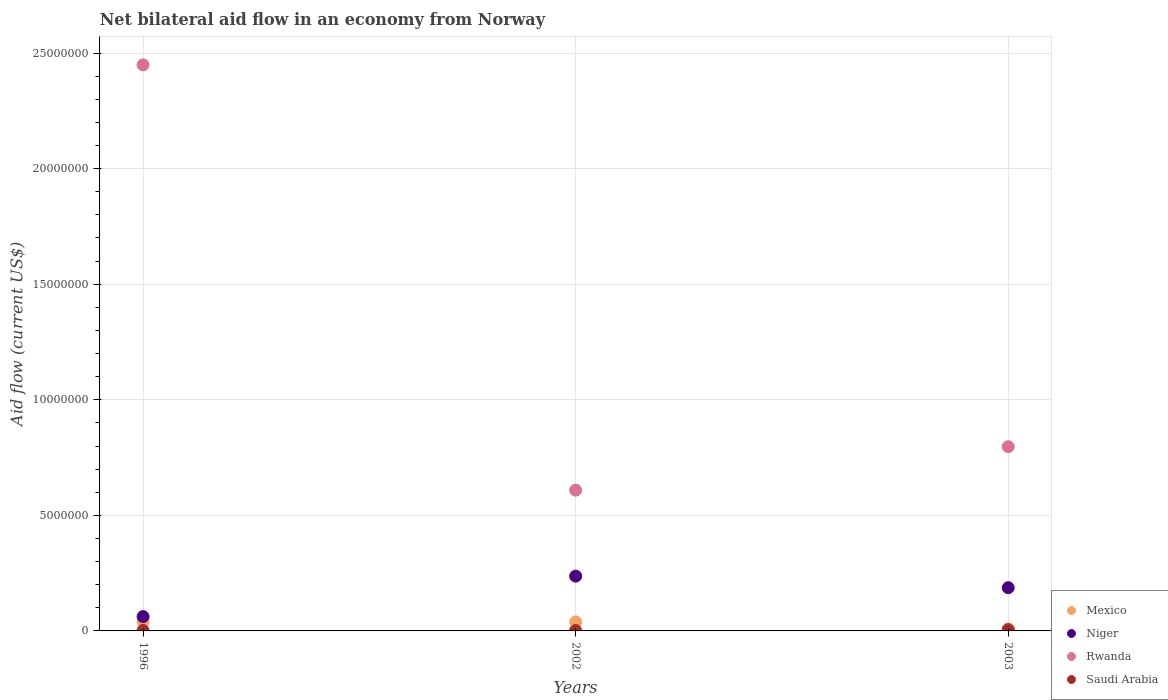How many different coloured dotlines are there?
Ensure brevity in your answer.  4. What is the net bilateral aid flow in Niger in 1996?
Your answer should be very brief. 6.20e+05. In which year was the net bilateral aid flow in Saudi Arabia maximum?
Provide a short and direct response. 2003. In which year was the net bilateral aid flow in Niger minimum?
Offer a terse response. 1996. What is the total net bilateral aid flow in Niger in the graph?
Provide a short and direct response. 4.86e+06. What is the difference between the net bilateral aid flow in Mexico in 2002 and the net bilateral aid flow in Niger in 2003?
Your answer should be compact. -1.48e+06. What is the average net bilateral aid flow in Saudi Arabia per year?
Ensure brevity in your answer.  3.00e+04. In the year 2003, what is the difference between the net bilateral aid flow in Saudi Arabia and net bilateral aid flow in Rwanda?
Offer a terse response. -7.92e+06. In how many years, is the net bilateral aid flow in Saudi Arabia greater than 14000000 US$?
Offer a very short reply. 0. What is the ratio of the net bilateral aid flow in Niger in 2002 to that in 2003?
Make the answer very short. 1.27. Is the net bilateral aid flow in Mexico in 1996 less than that in 2003?
Provide a succinct answer. No. What is the difference between the highest and the second highest net bilateral aid flow in Rwanda?
Give a very brief answer. 1.65e+07. What is the difference between the highest and the lowest net bilateral aid flow in Niger?
Make the answer very short. 1.75e+06. Is the sum of the net bilateral aid flow in Saudi Arabia in 1996 and 2003 greater than the maximum net bilateral aid flow in Rwanda across all years?
Provide a succinct answer. No. Does the net bilateral aid flow in Niger monotonically increase over the years?
Provide a succinct answer. No. Is the net bilateral aid flow in Rwanda strictly less than the net bilateral aid flow in Saudi Arabia over the years?
Keep it short and to the point. No. How many dotlines are there?
Give a very brief answer. 4. How many years are there in the graph?
Keep it short and to the point. 3. What is the difference between two consecutive major ticks on the Y-axis?
Make the answer very short. 5.00e+06. Are the values on the major ticks of Y-axis written in scientific E-notation?
Your answer should be compact. No. Does the graph contain any zero values?
Ensure brevity in your answer.  No. Where does the legend appear in the graph?
Provide a short and direct response. Bottom right. How many legend labels are there?
Provide a succinct answer. 4. What is the title of the graph?
Offer a very short reply. Net bilateral aid flow in an economy from Norway. What is the Aid flow (current US$) in Mexico in 1996?
Keep it short and to the point. 3.80e+05. What is the Aid flow (current US$) in Niger in 1996?
Your answer should be compact. 6.20e+05. What is the Aid flow (current US$) in Rwanda in 1996?
Give a very brief answer. 2.45e+07. What is the Aid flow (current US$) of Saudi Arabia in 1996?
Make the answer very short. 2.00e+04. What is the Aid flow (current US$) of Niger in 2002?
Make the answer very short. 2.37e+06. What is the Aid flow (current US$) in Rwanda in 2002?
Provide a short and direct response. 6.09e+06. What is the Aid flow (current US$) in Mexico in 2003?
Provide a short and direct response. 9.00e+04. What is the Aid flow (current US$) of Niger in 2003?
Your answer should be compact. 1.87e+06. What is the Aid flow (current US$) of Rwanda in 2003?
Your response must be concise. 7.97e+06. Across all years, what is the maximum Aid flow (current US$) in Niger?
Make the answer very short. 2.37e+06. Across all years, what is the maximum Aid flow (current US$) of Rwanda?
Your answer should be very brief. 2.45e+07. Across all years, what is the minimum Aid flow (current US$) in Niger?
Your response must be concise. 6.20e+05. Across all years, what is the minimum Aid flow (current US$) in Rwanda?
Your response must be concise. 6.09e+06. Across all years, what is the minimum Aid flow (current US$) of Saudi Arabia?
Provide a short and direct response. 2.00e+04. What is the total Aid flow (current US$) of Mexico in the graph?
Provide a short and direct response. 8.60e+05. What is the total Aid flow (current US$) of Niger in the graph?
Ensure brevity in your answer.  4.86e+06. What is the total Aid flow (current US$) of Rwanda in the graph?
Make the answer very short. 3.86e+07. What is the difference between the Aid flow (current US$) of Mexico in 1996 and that in 2002?
Offer a very short reply. -10000. What is the difference between the Aid flow (current US$) in Niger in 1996 and that in 2002?
Provide a short and direct response. -1.75e+06. What is the difference between the Aid flow (current US$) in Rwanda in 1996 and that in 2002?
Provide a succinct answer. 1.84e+07. What is the difference between the Aid flow (current US$) in Saudi Arabia in 1996 and that in 2002?
Provide a succinct answer. 0. What is the difference between the Aid flow (current US$) in Mexico in 1996 and that in 2003?
Give a very brief answer. 2.90e+05. What is the difference between the Aid flow (current US$) in Niger in 1996 and that in 2003?
Provide a short and direct response. -1.25e+06. What is the difference between the Aid flow (current US$) of Rwanda in 1996 and that in 2003?
Make the answer very short. 1.65e+07. What is the difference between the Aid flow (current US$) in Saudi Arabia in 1996 and that in 2003?
Your response must be concise. -3.00e+04. What is the difference between the Aid flow (current US$) in Niger in 2002 and that in 2003?
Offer a terse response. 5.00e+05. What is the difference between the Aid flow (current US$) of Rwanda in 2002 and that in 2003?
Give a very brief answer. -1.88e+06. What is the difference between the Aid flow (current US$) of Saudi Arabia in 2002 and that in 2003?
Offer a very short reply. -3.00e+04. What is the difference between the Aid flow (current US$) of Mexico in 1996 and the Aid flow (current US$) of Niger in 2002?
Provide a short and direct response. -1.99e+06. What is the difference between the Aid flow (current US$) of Mexico in 1996 and the Aid flow (current US$) of Rwanda in 2002?
Your response must be concise. -5.71e+06. What is the difference between the Aid flow (current US$) of Mexico in 1996 and the Aid flow (current US$) of Saudi Arabia in 2002?
Ensure brevity in your answer.  3.60e+05. What is the difference between the Aid flow (current US$) in Niger in 1996 and the Aid flow (current US$) in Rwanda in 2002?
Make the answer very short. -5.47e+06. What is the difference between the Aid flow (current US$) in Rwanda in 1996 and the Aid flow (current US$) in Saudi Arabia in 2002?
Give a very brief answer. 2.45e+07. What is the difference between the Aid flow (current US$) of Mexico in 1996 and the Aid flow (current US$) of Niger in 2003?
Provide a short and direct response. -1.49e+06. What is the difference between the Aid flow (current US$) in Mexico in 1996 and the Aid flow (current US$) in Rwanda in 2003?
Your answer should be compact. -7.59e+06. What is the difference between the Aid flow (current US$) of Niger in 1996 and the Aid flow (current US$) of Rwanda in 2003?
Make the answer very short. -7.35e+06. What is the difference between the Aid flow (current US$) in Niger in 1996 and the Aid flow (current US$) in Saudi Arabia in 2003?
Provide a short and direct response. 5.70e+05. What is the difference between the Aid flow (current US$) of Rwanda in 1996 and the Aid flow (current US$) of Saudi Arabia in 2003?
Your answer should be compact. 2.44e+07. What is the difference between the Aid flow (current US$) of Mexico in 2002 and the Aid flow (current US$) of Niger in 2003?
Keep it short and to the point. -1.48e+06. What is the difference between the Aid flow (current US$) in Mexico in 2002 and the Aid flow (current US$) in Rwanda in 2003?
Ensure brevity in your answer.  -7.58e+06. What is the difference between the Aid flow (current US$) of Mexico in 2002 and the Aid flow (current US$) of Saudi Arabia in 2003?
Ensure brevity in your answer.  3.40e+05. What is the difference between the Aid flow (current US$) in Niger in 2002 and the Aid flow (current US$) in Rwanda in 2003?
Your response must be concise. -5.60e+06. What is the difference between the Aid flow (current US$) of Niger in 2002 and the Aid flow (current US$) of Saudi Arabia in 2003?
Give a very brief answer. 2.32e+06. What is the difference between the Aid flow (current US$) in Rwanda in 2002 and the Aid flow (current US$) in Saudi Arabia in 2003?
Ensure brevity in your answer.  6.04e+06. What is the average Aid flow (current US$) of Mexico per year?
Give a very brief answer. 2.87e+05. What is the average Aid flow (current US$) in Niger per year?
Provide a succinct answer. 1.62e+06. What is the average Aid flow (current US$) in Rwanda per year?
Ensure brevity in your answer.  1.28e+07. In the year 1996, what is the difference between the Aid flow (current US$) in Mexico and Aid flow (current US$) in Rwanda?
Your answer should be compact. -2.41e+07. In the year 1996, what is the difference between the Aid flow (current US$) in Niger and Aid flow (current US$) in Rwanda?
Your response must be concise. -2.39e+07. In the year 1996, what is the difference between the Aid flow (current US$) in Niger and Aid flow (current US$) in Saudi Arabia?
Ensure brevity in your answer.  6.00e+05. In the year 1996, what is the difference between the Aid flow (current US$) in Rwanda and Aid flow (current US$) in Saudi Arabia?
Make the answer very short. 2.45e+07. In the year 2002, what is the difference between the Aid flow (current US$) of Mexico and Aid flow (current US$) of Niger?
Provide a short and direct response. -1.98e+06. In the year 2002, what is the difference between the Aid flow (current US$) in Mexico and Aid flow (current US$) in Rwanda?
Your answer should be very brief. -5.70e+06. In the year 2002, what is the difference between the Aid flow (current US$) in Mexico and Aid flow (current US$) in Saudi Arabia?
Offer a very short reply. 3.70e+05. In the year 2002, what is the difference between the Aid flow (current US$) of Niger and Aid flow (current US$) of Rwanda?
Keep it short and to the point. -3.72e+06. In the year 2002, what is the difference between the Aid flow (current US$) in Niger and Aid flow (current US$) in Saudi Arabia?
Offer a very short reply. 2.35e+06. In the year 2002, what is the difference between the Aid flow (current US$) in Rwanda and Aid flow (current US$) in Saudi Arabia?
Offer a very short reply. 6.07e+06. In the year 2003, what is the difference between the Aid flow (current US$) in Mexico and Aid flow (current US$) in Niger?
Ensure brevity in your answer.  -1.78e+06. In the year 2003, what is the difference between the Aid flow (current US$) of Mexico and Aid flow (current US$) of Rwanda?
Your response must be concise. -7.88e+06. In the year 2003, what is the difference between the Aid flow (current US$) in Niger and Aid flow (current US$) in Rwanda?
Your response must be concise. -6.10e+06. In the year 2003, what is the difference between the Aid flow (current US$) in Niger and Aid flow (current US$) in Saudi Arabia?
Provide a succinct answer. 1.82e+06. In the year 2003, what is the difference between the Aid flow (current US$) of Rwanda and Aid flow (current US$) of Saudi Arabia?
Make the answer very short. 7.92e+06. What is the ratio of the Aid flow (current US$) of Mexico in 1996 to that in 2002?
Ensure brevity in your answer.  0.97. What is the ratio of the Aid flow (current US$) in Niger in 1996 to that in 2002?
Ensure brevity in your answer.  0.26. What is the ratio of the Aid flow (current US$) of Rwanda in 1996 to that in 2002?
Offer a very short reply. 4.02. What is the ratio of the Aid flow (current US$) in Saudi Arabia in 1996 to that in 2002?
Offer a very short reply. 1. What is the ratio of the Aid flow (current US$) of Mexico in 1996 to that in 2003?
Give a very brief answer. 4.22. What is the ratio of the Aid flow (current US$) of Niger in 1996 to that in 2003?
Your answer should be compact. 0.33. What is the ratio of the Aid flow (current US$) in Rwanda in 1996 to that in 2003?
Offer a very short reply. 3.07. What is the ratio of the Aid flow (current US$) of Mexico in 2002 to that in 2003?
Offer a very short reply. 4.33. What is the ratio of the Aid flow (current US$) in Niger in 2002 to that in 2003?
Keep it short and to the point. 1.27. What is the ratio of the Aid flow (current US$) in Rwanda in 2002 to that in 2003?
Provide a succinct answer. 0.76. What is the ratio of the Aid flow (current US$) of Saudi Arabia in 2002 to that in 2003?
Your response must be concise. 0.4. What is the difference between the highest and the second highest Aid flow (current US$) of Rwanda?
Your answer should be compact. 1.65e+07. What is the difference between the highest and the lowest Aid flow (current US$) in Mexico?
Offer a very short reply. 3.00e+05. What is the difference between the highest and the lowest Aid flow (current US$) in Niger?
Your answer should be compact. 1.75e+06. What is the difference between the highest and the lowest Aid flow (current US$) of Rwanda?
Provide a short and direct response. 1.84e+07. What is the difference between the highest and the lowest Aid flow (current US$) in Saudi Arabia?
Provide a short and direct response. 3.00e+04. 